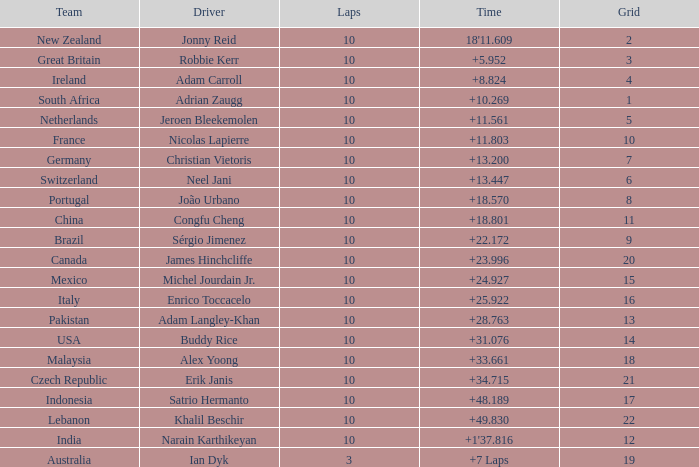What is the Grid number for the Team from Italy? 1.0. 